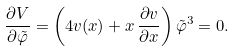<formula> <loc_0><loc_0><loc_500><loc_500>\frac { \partial V } { \partial \tilde { \varphi } } = \left ( 4 v ( x ) + x \, \frac { \partial v } { \partial x } \right ) \tilde { \varphi } ^ { 3 } = 0 .</formula> 